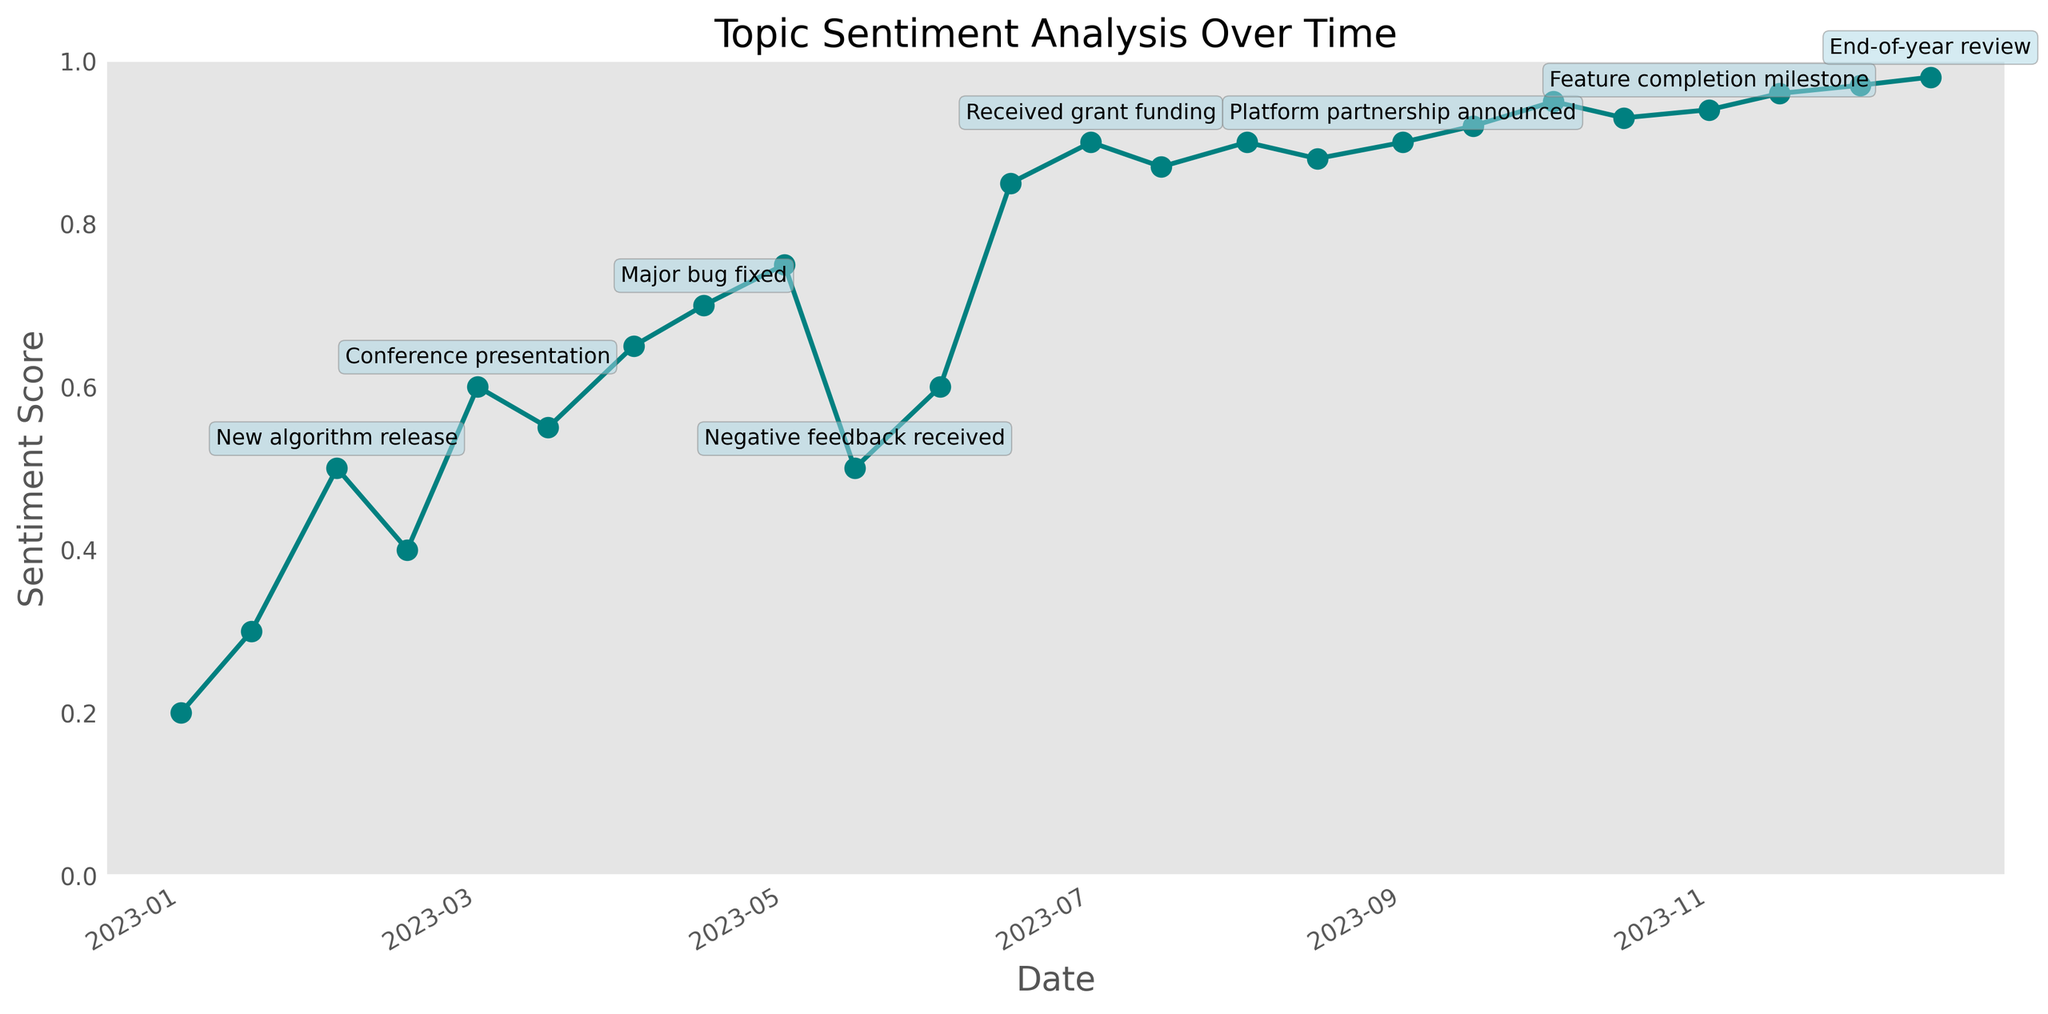What is the trend of the sentiment score throughout 2023? The sentiment score shows an overall increasing trend throughout the year. Initially, the score is low and steadily increases with a few fluctuations, eventually reaching its peak at the end of the year.
Answer: Overall increasing trend When did the sentiment score experience the most significant drop? The most significant drop in sentiment score occurs between May 1 and May 15. The sentiment score drops from 0.75 to 0.5.
Answer: Between May 1 and May 15 What was the sentiment score on the date when "Received grant funding" occurred? Locate the date of "Received grant funding" on the chart, which is July 1. The sentiment score on this date is 0.9.
Answer: 0.9 Was the sentiment score ever the same on different dates? After reviewing the trend line, the sentiment scores are identical on multiple dates. One example is 0.9, which occurs on July 1, August 1, and September 1.
Answer: Yes How many key events are annotated in the figure? Count the number of annotations along the trend line that indicate key events. There are a total of 10 key events annotated.
Answer: 10 Which event correlates with the highest sentiment score increase between consecutive measurements? Compare the sentiment score increase between consecutive measurement points for each event. The sentiment score increase is highest between June 15 (0.85) and July 1 (0.9) when "Received grant funding" occurred.
Answer: "Received grant funding" What is the sentiment score difference between the "New algorithm release" and "Negative feedback received"? The sentiment score for "New algorithm release" (February 1) is 0.5. The sentiment score for "Negative feedback received" (May 15) is 0.5. The difference is 0 (0.5 - 0.5).
Answer: 0 Which month had the highest average sentiment score? Calculate the average sentiment score for each month. July has the highest average score with values of 0.9 and 0.87, resulting in an average of (0.9 + 0.87) / 2 = 0.885.
Answer: July If we remove the "Negative feedback received" event, what would be the overall sentiment trend? Removing the "Negative feedback received" event (May 15, sentiment score 0.5) would show a more consistently increasing trend without a significant drop during the year. The trend line would continue to rise more smoothly.
Answer: More consistently increasing trend 